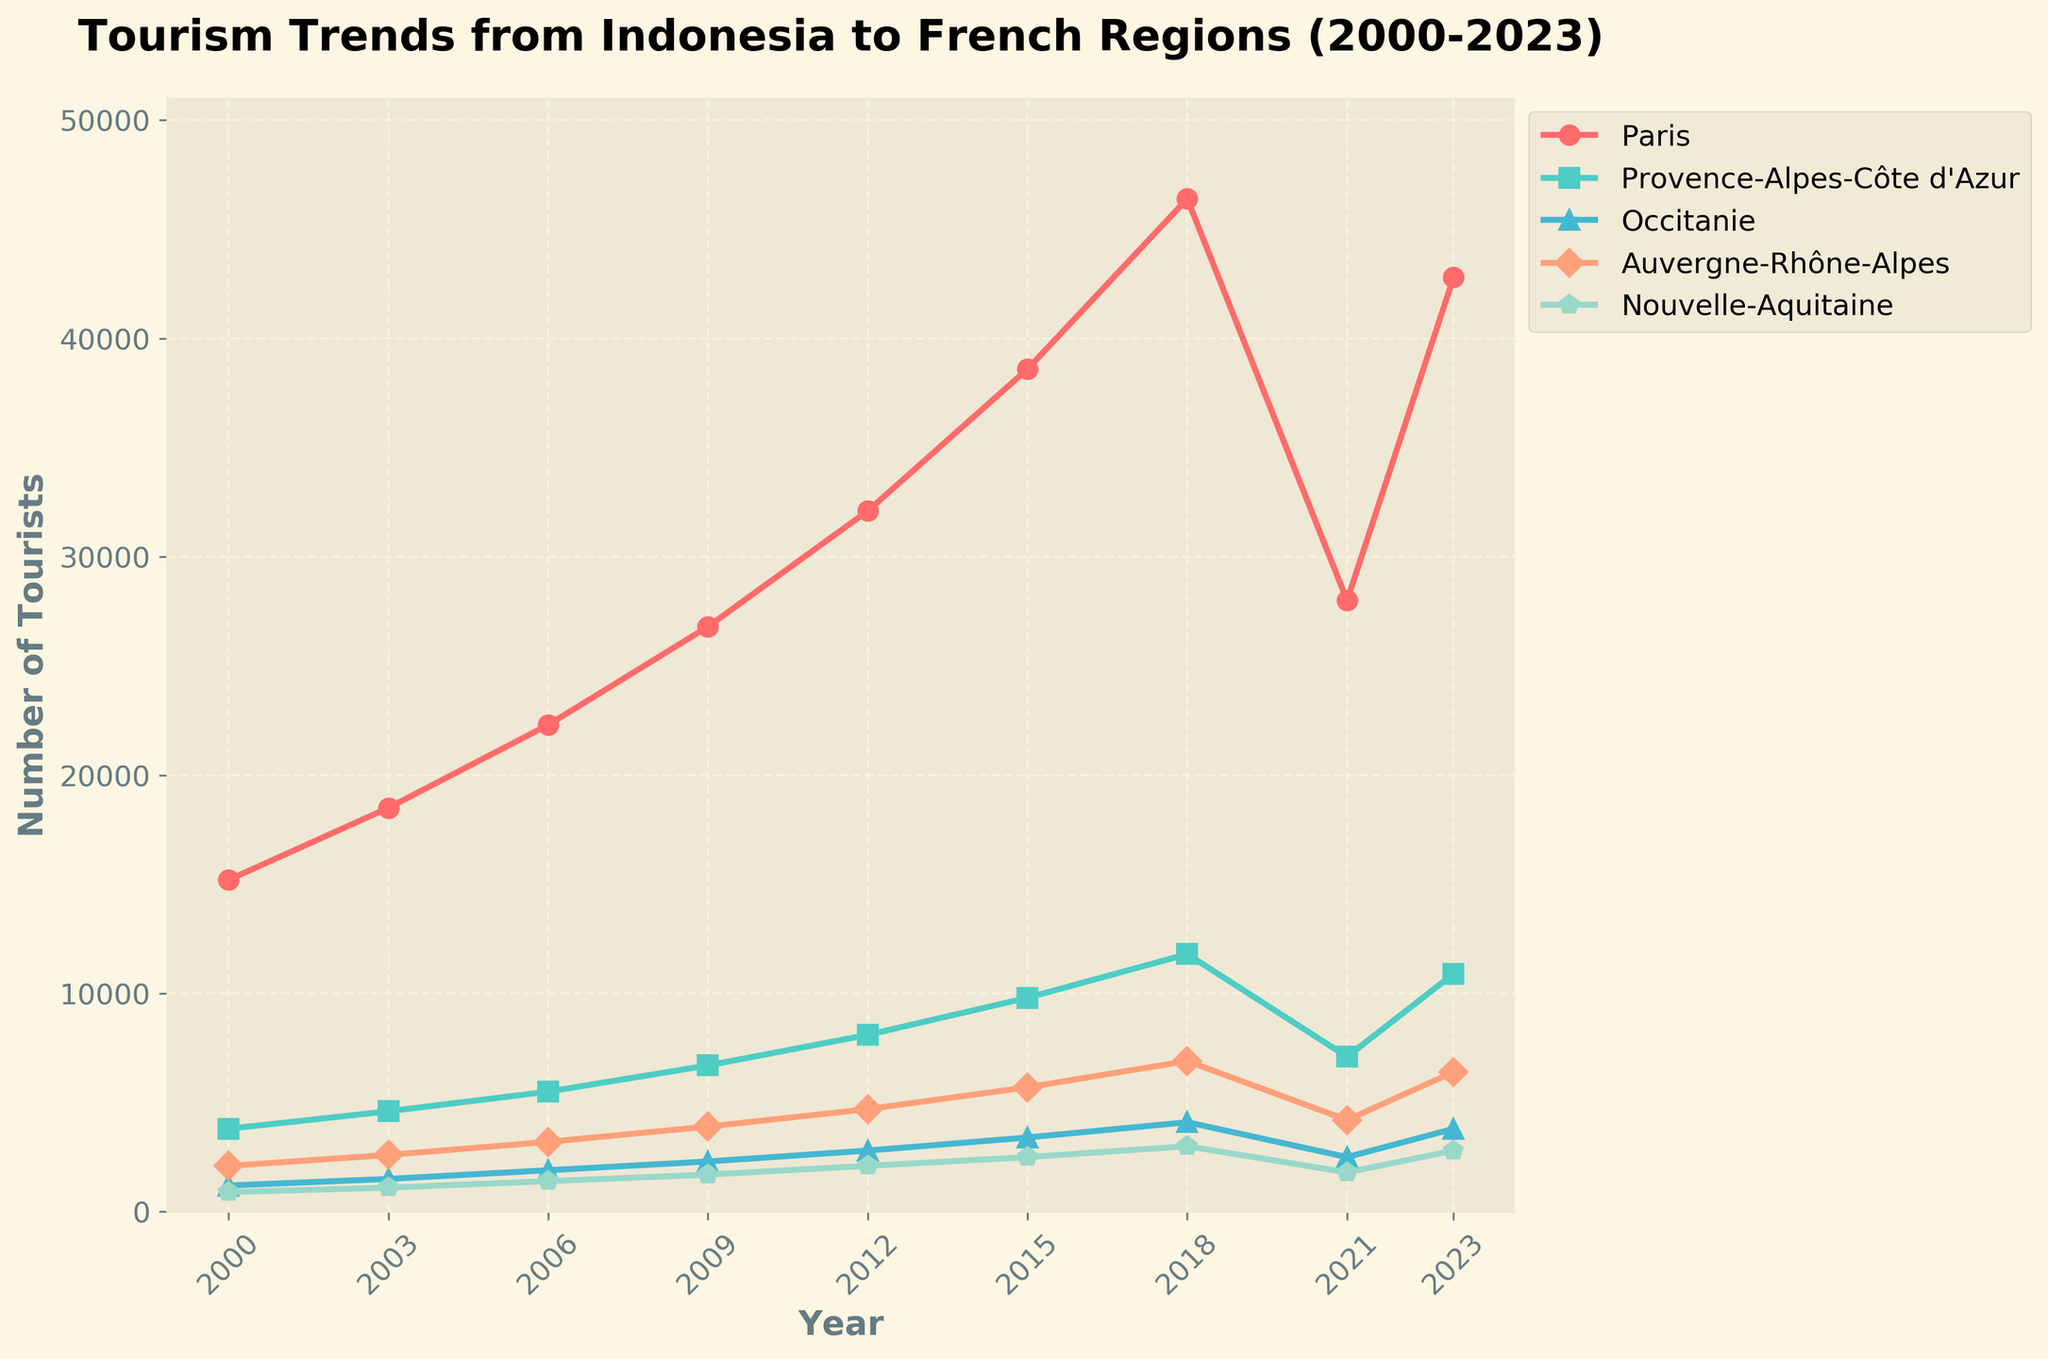What is the overall trend in the number of tourists from Indonesia to Paris between 2000 and 2023? The overall trend shows an increase in the number of tourists from Indonesia to Paris, starting at 15,200 in 2000 and rising to 42,800 in 2023, despite a noticeable dip in 2021.
Answer: Increasing trend In which year did Provence-Alpes-Côte d'Azur see the highest number of Indonesian tourists? By observing the plot, Provence-Alpes-Côte d'Azur saw the highest number of Indonesian tourists in 2018, reaching 11,800.
Answer: 2018 Which region had the smallest number of tourists from Indonesia in 2023? By comparing the endpoints of the lines, Nouvelle-Aquitaine had the smallest number of tourists in 2023 with 2,800.
Answer: Nouvelle-Aquitaine How did the number of tourists to Occitanie change between 2018 and 2021? From the figure, Occitanie had 4,100 tourists in 2018 and 2,500 in 2021, showing a decrease.
Answer: Decreased What is the difference in the number of tourists between 2015 and 2021 for Auvergne-Rhône-Alpes? In 2015, Auvergne-Rhône-Alpes had 5,700 tourists, and in 2021 it had 4,200 tourists. The difference is 1,500 tourists.
Answer: 1,500 Which region experienced the largest drop in tourists from 2018 to 2021? Observing the decline from 2018 to 2021 for each region, Paris experienced the largest drop, falling from 46,400 to 28,000, a difference of 18,400 tourists.
Answer: Paris Between 2000 and 2023, in which year did Nouvelle-Aquitaine see more tourists than Occitanie? By comparing the data from the plot, the year 2003 shows Nouvelle-Aquitaine (1,100 tourists) had more tourists than Occitanie (900 tourists).
Answer: 2003 Which region had a steady growth trend without any decline from 2000 to 2023? Observing all the regions' plots, Auvergne-Rhône-Alpes shows a consistent increase in tourists without any decline between 2000 and 2023, except for the dip in 2021.
Answer: None (All regions had declines due to the dip in 2021) What are the colors used to represent Paris and Occitanie in the plot? Paris is represented by the red line, and Occitanie is represented by the green line.
Answer: Red for Paris, green for Occitanie What is the average number of tourists visiting Provence-Alpes-Côte d'Azur from 2000 to 2023? Sum up the numbers for Provence-Alpes-Côte d'Azur: (3,800 + 4,600 + 5,500 + 6,700 + 8,100 + 9,800 + 11,800 + 7,100 + 10,900) = 68,300. There are 9 data points, so the average is 68,300 / 9 ≈ 7,589 tourists.
Answer: 7,589 